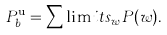Convert formula to latex. <formula><loc_0><loc_0><loc_500><loc_500>P _ { b } ^ { \text {u} } = \sum \lim i t s _ { w } P ( w ) .</formula> 